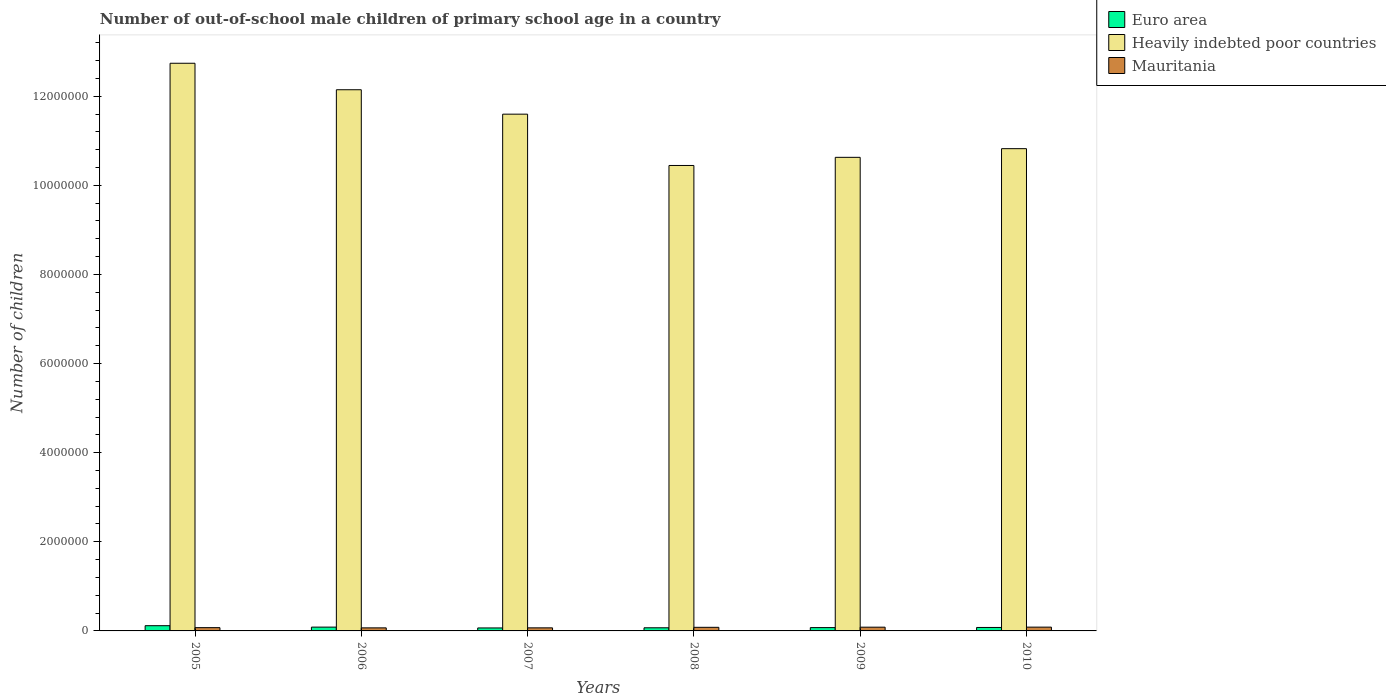How many groups of bars are there?
Offer a very short reply. 6. Are the number of bars per tick equal to the number of legend labels?
Make the answer very short. Yes. How many bars are there on the 6th tick from the left?
Ensure brevity in your answer.  3. How many bars are there on the 4th tick from the right?
Keep it short and to the point. 3. What is the label of the 1st group of bars from the left?
Your response must be concise. 2005. In how many cases, is the number of bars for a given year not equal to the number of legend labels?
Give a very brief answer. 0. What is the number of out-of-school male children in Heavily indebted poor countries in 2008?
Ensure brevity in your answer.  1.04e+07. Across all years, what is the maximum number of out-of-school male children in Heavily indebted poor countries?
Offer a very short reply. 1.27e+07. Across all years, what is the minimum number of out-of-school male children in Heavily indebted poor countries?
Provide a short and direct response. 1.04e+07. In which year was the number of out-of-school male children in Heavily indebted poor countries minimum?
Your answer should be very brief. 2008. What is the total number of out-of-school male children in Mauritania in the graph?
Give a very brief answer. 4.60e+05. What is the difference between the number of out-of-school male children in Mauritania in 2009 and that in 2010?
Provide a succinct answer. -984. What is the difference between the number of out-of-school male children in Mauritania in 2007 and the number of out-of-school male children in Heavily indebted poor countries in 2010?
Your answer should be compact. -1.08e+07. What is the average number of out-of-school male children in Heavily indebted poor countries per year?
Ensure brevity in your answer.  1.14e+07. In the year 2007, what is the difference between the number of out-of-school male children in Euro area and number of out-of-school male children in Mauritania?
Your answer should be compact. -1916. What is the ratio of the number of out-of-school male children in Heavily indebted poor countries in 2005 to that in 2010?
Provide a succinct answer. 1.18. What is the difference between the highest and the second highest number of out-of-school male children in Mauritania?
Provide a succinct answer. 984. What is the difference between the highest and the lowest number of out-of-school male children in Mauritania?
Your response must be concise. 1.65e+04. Is the sum of the number of out-of-school male children in Euro area in 2006 and 2008 greater than the maximum number of out-of-school male children in Heavily indebted poor countries across all years?
Your answer should be compact. No. What does the 2nd bar from the left in 2005 represents?
Ensure brevity in your answer.  Heavily indebted poor countries. What does the 2nd bar from the right in 2007 represents?
Make the answer very short. Heavily indebted poor countries. Are all the bars in the graph horizontal?
Your response must be concise. No. How many years are there in the graph?
Keep it short and to the point. 6. Are the values on the major ticks of Y-axis written in scientific E-notation?
Make the answer very short. No. Does the graph contain any zero values?
Give a very brief answer. No. Does the graph contain grids?
Your response must be concise. No. How many legend labels are there?
Your answer should be compact. 3. What is the title of the graph?
Offer a terse response. Number of out-of-school male children of primary school age in a country. What is the label or title of the X-axis?
Keep it short and to the point. Years. What is the label or title of the Y-axis?
Make the answer very short. Number of children. What is the Number of children of Euro area in 2005?
Provide a succinct answer. 1.17e+05. What is the Number of children in Heavily indebted poor countries in 2005?
Offer a terse response. 1.27e+07. What is the Number of children in Mauritania in 2005?
Offer a very short reply. 7.36e+04. What is the Number of children of Euro area in 2006?
Your response must be concise. 8.54e+04. What is the Number of children in Heavily indebted poor countries in 2006?
Ensure brevity in your answer.  1.21e+07. What is the Number of children of Mauritania in 2006?
Keep it short and to the point. 6.84e+04. What is the Number of children of Euro area in 2007?
Keep it short and to the point. 6.70e+04. What is the Number of children of Heavily indebted poor countries in 2007?
Offer a very short reply. 1.16e+07. What is the Number of children of Mauritania in 2007?
Your answer should be compact. 6.89e+04. What is the Number of children of Euro area in 2008?
Ensure brevity in your answer.  7.04e+04. What is the Number of children in Heavily indebted poor countries in 2008?
Provide a short and direct response. 1.04e+07. What is the Number of children of Mauritania in 2008?
Keep it short and to the point. 8.08e+04. What is the Number of children in Euro area in 2009?
Provide a short and direct response. 7.44e+04. What is the Number of children in Heavily indebted poor countries in 2009?
Offer a very short reply. 1.06e+07. What is the Number of children of Mauritania in 2009?
Your response must be concise. 8.39e+04. What is the Number of children in Euro area in 2010?
Offer a terse response. 7.76e+04. What is the Number of children in Heavily indebted poor countries in 2010?
Give a very brief answer. 1.08e+07. What is the Number of children of Mauritania in 2010?
Make the answer very short. 8.49e+04. Across all years, what is the maximum Number of children of Euro area?
Provide a short and direct response. 1.17e+05. Across all years, what is the maximum Number of children in Heavily indebted poor countries?
Provide a succinct answer. 1.27e+07. Across all years, what is the maximum Number of children in Mauritania?
Provide a short and direct response. 8.49e+04. Across all years, what is the minimum Number of children of Euro area?
Give a very brief answer. 6.70e+04. Across all years, what is the minimum Number of children in Heavily indebted poor countries?
Make the answer very short. 1.04e+07. Across all years, what is the minimum Number of children in Mauritania?
Make the answer very short. 6.84e+04. What is the total Number of children in Euro area in the graph?
Provide a succinct answer. 4.92e+05. What is the total Number of children of Heavily indebted poor countries in the graph?
Keep it short and to the point. 6.84e+07. What is the total Number of children in Mauritania in the graph?
Your answer should be very brief. 4.60e+05. What is the difference between the Number of children in Euro area in 2005 and that in 2006?
Your answer should be very brief. 3.19e+04. What is the difference between the Number of children in Heavily indebted poor countries in 2005 and that in 2006?
Make the answer very short. 5.94e+05. What is the difference between the Number of children of Mauritania in 2005 and that in 2006?
Provide a succinct answer. 5196. What is the difference between the Number of children of Euro area in 2005 and that in 2007?
Keep it short and to the point. 5.03e+04. What is the difference between the Number of children in Heavily indebted poor countries in 2005 and that in 2007?
Provide a succinct answer. 1.14e+06. What is the difference between the Number of children in Mauritania in 2005 and that in 2007?
Your answer should be compact. 4740. What is the difference between the Number of children of Euro area in 2005 and that in 2008?
Give a very brief answer. 4.69e+04. What is the difference between the Number of children of Heavily indebted poor countries in 2005 and that in 2008?
Offer a terse response. 2.29e+06. What is the difference between the Number of children of Mauritania in 2005 and that in 2008?
Your response must be concise. -7215. What is the difference between the Number of children in Euro area in 2005 and that in 2009?
Provide a short and direct response. 4.28e+04. What is the difference between the Number of children in Heavily indebted poor countries in 2005 and that in 2009?
Your answer should be compact. 2.11e+06. What is the difference between the Number of children of Mauritania in 2005 and that in 2009?
Your answer should be compact. -1.03e+04. What is the difference between the Number of children in Euro area in 2005 and that in 2010?
Provide a succinct answer. 3.97e+04. What is the difference between the Number of children in Heavily indebted poor countries in 2005 and that in 2010?
Provide a succinct answer. 1.92e+06. What is the difference between the Number of children in Mauritania in 2005 and that in 2010?
Offer a terse response. -1.13e+04. What is the difference between the Number of children in Euro area in 2006 and that in 2007?
Your response must be concise. 1.84e+04. What is the difference between the Number of children of Heavily indebted poor countries in 2006 and that in 2007?
Offer a very short reply. 5.48e+05. What is the difference between the Number of children in Mauritania in 2006 and that in 2007?
Give a very brief answer. -456. What is the difference between the Number of children of Euro area in 2006 and that in 2008?
Your answer should be compact. 1.50e+04. What is the difference between the Number of children in Heavily indebted poor countries in 2006 and that in 2008?
Your response must be concise. 1.70e+06. What is the difference between the Number of children of Mauritania in 2006 and that in 2008?
Your response must be concise. -1.24e+04. What is the difference between the Number of children in Euro area in 2006 and that in 2009?
Ensure brevity in your answer.  1.09e+04. What is the difference between the Number of children of Heavily indebted poor countries in 2006 and that in 2009?
Offer a terse response. 1.52e+06. What is the difference between the Number of children in Mauritania in 2006 and that in 2009?
Make the answer very short. -1.55e+04. What is the difference between the Number of children in Euro area in 2006 and that in 2010?
Provide a succinct answer. 7785. What is the difference between the Number of children in Heavily indebted poor countries in 2006 and that in 2010?
Your answer should be very brief. 1.32e+06. What is the difference between the Number of children of Mauritania in 2006 and that in 2010?
Ensure brevity in your answer.  -1.65e+04. What is the difference between the Number of children of Euro area in 2007 and that in 2008?
Ensure brevity in your answer.  -3445. What is the difference between the Number of children of Heavily indebted poor countries in 2007 and that in 2008?
Your response must be concise. 1.15e+06. What is the difference between the Number of children in Mauritania in 2007 and that in 2008?
Make the answer very short. -1.20e+04. What is the difference between the Number of children in Euro area in 2007 and that in 2009?
Your answer should be very brief. -7489. What is the difference between the Number of children of Heavily indebted poor countries in 2007 and that in 2009?
Offer a very short reply. 9.69e+05. What is the difference between the Number of children of Mauritania in 2007 and that in 2009?
Give a very brief answer. -1.50e+04. What is the difference between the Number of children in Euro area in 2007 and that in 2010?
Give a very brief answer. -1.06e+04. What is the difference between the Number of children in Heavily indebted poor countries in 2007 and that in 2010?
Keep it short and to the point. 7.74e+05. What is the difference between the Number of children in Mauritania in 2007 and that in 2010?
Give a very brief answer. -1.60e+04. What is the difference between the Number of children of Euro area in 2008 and that in 2009?
Provide a short and direct response. -4044. What is the difference between the Number of children in Heavily indebted poor countries in 2008 and that in 2009?
Provide a short and direct response. -1.83e+05. What is the difference between the Number of children in Mauritania in 2008 and that in 2009?
Ensure brevity in your answer.  -3057. What is the difference between the Number of children in Euro area in 2008 and that in 2010?
Your response must be concise. -7186. What is the difference between the Number of children in Heavily indebted poor countries in 2008 and that in 2010?
Your response must be concise. -3.77e+05. What is the difference between the Number of children of Mauritania in 2008 and that in 2010?
Your answer should be very brief. -4041. What is the difference between the Number of children of Euro area in 2009 and that in 2010?
Provide a short and direct response. -3142. What is the difference between the Number of children of Heavily indebted poor countries in 2009 and that in 2010?
Your answer should be compact. -1.95e+05. What is the difference between the Number of children of Mauritania in 2009 and that in 2010?
Make the answer very short. -984. What is the difference between the Number of children in Euro area in 2005 and the Number of children in Heavily indebted poor countries in 2006?
Your response must be concise. -1.20e+07. What is the difference between the Number of children in Euro area in 2005 and the Number of children in Mauritania in 2006?
Give a very brief answer. 4.89e+04. What is the difference between the Number of children of Heavily indebted poor countries in 2005 and the Number of children of Mauritania in 2006?
Your response must be concise. 1.27e+07. What is the difference between the Number of children in Euro area in 2005 and the Number of children in Heavily indebted poor countries in 2007?
Your answer should be compact. -1.15e+07. What is the difference between the Number of children in Euro area in 2005 and the Number of children in Mauritania in 2007?
Provide a succinct answer. 4.84e+04. What is the difference between the Number of children in Heavily indebted poor countries in 2005 and the Number of children in Mauritania in 2007?
Ensure brevity in your answer.  1.27e+07. What is the difference between the Number of children in Euro area in 2005 and the Number of children in Heavily indebted poor countries in 2008?
Your answer should be very brief. -1.03e+07. What is the difference between the Number of children in Euro area in 2005 and the Number of children in Mauritania in 2008?
Provide a short and direct response. 3.65e+04. What is the difference between the Number of children in Heavily indebted poor countries in 2005 and the Number of children in Mauritania in 2008?
Give a very brief answer. 1.27e+07. What is the difference between the Number of children in Euro area in 2005 and the Number of children in Heavily indebted poor countries in 2009?
Keep it short and to the point. -1.05e+07. What is the difference between the Number of children in Euro area in 2005 and the Number of children in Mauritania in 2009?
Keep it short and to the point. 3.34e+04. What is the difference between the Number of children of Heavily indebted poor countries in 2005 and the Number of children of Mauritania in 2009?
Provide a succinct answer. 1.27e+07. What is the difference between the Number of children of Euro area in 2005 and the Number of children of Heavily indebted poor countries in 2010?
Offer a terse response. -1.07e+07. What is the difference between the Number of children of Euro area in 2005 and the Number of children of Mauritania in 2010?
Provide a succinct answer. 3.24e+04. What is the difference between the Number of children in Heavily indebted poor countries in 2005 and the Number of children in Mauritania in 2010?
Ensure brevity in your answer.  1.27e+07. What is the difference between the Number of children in Euro area in 2006 and the Number of children in Heavily indebted poor countries in 2007?
Your response must be concise. -1.15e+07. What is the difference between the Number of children in Euro area in 2006 and the Number of children in Mauritania in 2007?
Your response must be concise. 1.65e+04. What is the difference between the Number of children of Heavily indebted poor countries in 2006 and the Number of children of Mauritania in 2007?
Your response must be concise. 1.21e+07. What is the difference between the Number of children of Euro area in 2006 and the Number of children of Heavily indebted poor countries in 2008?
Offer a very short reply. -1.04e+07. What is the difference between the Number of children of Euro area in 2006 and the Number of children of Mauritania in 2008?
Your answer should be compact. 4545. What is the difference between the Number of children of Heavily indebted poor countries in 2006 and the Number of children of Mauritania in 2008?
Offer a terse response. 1.21e+07. What is the difference between the Number of children of Euro area in 2006 and the Number of children of Heavily indebted poor countries in 2009?
Provide a short and direct response. -1.05e+07. What is the difference between the Number of children in Euro area in 2006 and the Number of children in Mauritania in 2009?
Give a very brief answer. 1488. What is the difference between the Number of children in Heavily indebted poor countries in 2006 and the Number of children in Mauritania in 2009?
Provide a succinct answer. 1.21e+07. What is the difference between the Number of children of Euro area in 2006 and the Number of children of Heavily indebted poor countries in 2010?
Make the answer very short. -1.07e+07. What is the difference between the Number of children of Euro area in 2006 and the Number of children of Mauritania in 2010?
Your answer should be compact. 504. What is the difference between the Number of children in Heavily indebted poor countries in 2006 and the Number of children in Mauritania in 2010?
Give a very brief answer. 1.21e+07. What is the difference between the Number of children in Euro area in 2007 and the Number of children in Heavily indebted poor countries in 2008?
Ensure brevity in your answer.  -1.04e+07. What is the difference between the Number of children in Euro area in 2007 and the Number of children in Mauritania in 2008?
Your answer should be very brief. -1.39e+04. What is the difference between the Number of children of Heavily indebted poor countries in 2007 and the Number of children of Mauritania in 2008?
Make the answer very short. 1.15e+07. What is the difference between the Number of children of Euro area in 2007 and the Number of children of Heavily indebted poor countries in 2009?
Provide a short and direct response. -1.06e+07. What is the difference between the Number of children in Euro area in 2007 and the Number of children in Mauritania in 2009?
Offer a very short reply. -1.69e+04. What is the difference between the Number of children of Heavily indebted poor countries in 2007 and the Number of children of Mauritania in 2009?
Offer a terse response. 1.15e+07. What is the difference between the Number of children in Euro area in 2007 and the Number of children in Heavily indebted poor countries in 2010?
Your response must be concise. -1.08e+07. What is the difference between the Number of children in Euro area in 2007 and the Number of children in Mauritania in 2010?
Ensure brevity in your answer.  -1.79e+04. What is the difference between the Number of children in Heavily indebted poor countries in 2007 and the Number of children in Mauritania in 2010?
Provide a succinct answer. 1.15e+07. What is the difference between the Number of children in Euro area in 2008 and the Number of children in Heavily indebted poor countries in 2009?
Provide a short and direct response. -1.06e+07. What is the difference between the Number of children in Euro area in 2008 and the Number of children in Mauritania in 2009?
Ensure brevity in your answer.  -1.35e+04. What is the difference between the Number of children in Heavily indebted poor countries in 2008 and the Number of children in Mauritania in 2009?
Offer a very short reply. 1.04e+07. What is the difference between the Number of children in Euro area in 2008 and the Number of children in Heavily indebted poor countries in 2010?
Your answer should be compact. -1.08e+07. What is the difference between the Number of children of Euro area in 2008 and the Number of children of Mauritania in 2010?
Your answer should be very brief. -1.45e+04. What is the difference between the Number of children of Heavily indebted poor countries in 2008 and the Number of children of Mauritania in 2010?
Your response must be concise. 1.04e+07. What is the difference between the Number of children of Euro area in 2009 and the Number of children of Heavily indebted poor countries in 2010?
Provide a succinct answer. -1.07e+07. What is the difference between the Number of children in Euro area in 2009 and the Number of children in Mauritania in 2010?
Ensure brevity in your answer.  -1.04e+04. What is the difference between the Number of children in Heavily indebted poor countries in 2009 and the Number of children in Mauritania in 2010?
Make the answer very short. 1.05e+07. What is the average Number of children of Euro area per year?
Give a very brief answer. 8.20e+04. What is the average Number of children in Heavily indebted poor countries per year?
Your response must be concise. 1.14e+07. What is the average Number of children in Mauritania per year?
Your response must be concise. 7.67e+04. In the year 2005, what is the difference between the Number of children of Euro area and Number of children of Heavily indebted poor countries?
Make the answer very short. -1.26e+07. In the year 2005, what is the difference between the Number of children in Euro area and Number of children in Mauritania?
Your response must be concise. 4.37e+04. In the year 2005, what is the difference between the Number of children of Heavily indebted poor countries and Number of children of Mauritania?
Your answer should be compact. 1.27e+07. In the year 2006, what is the difference between the Number of children of Euro area and Number of children of Heavily indebted poor countries?
Give a very brief answer. -1.21e+07. In the year 2006, what is the difference between the Number of children of Euro area and Number of children of Mauritania?
Ensure brevity in your answer.  1.70e+04. In the year 2006, what is the difference between the Number of children in Heavily indebted poor countries and Number of children in Mauritania?
Your response must be concise. 1.21e+07. In the year 2007, what is the difference between the Number of children in Euro area and Number of children in Heavily indebted poor countries?
Ensure brevity in your answer.  -1.15e+07. In the year 2007, what is the difference between the Number of children in Euro area and Number of children in Mauritania?
Make the answer very short. -1916. In the year 2007, what is the difference between the Number of children of Heavily indebted poor countries and Number of children of Mauritania?
Your answer should be compact. 1.15e+07. In the year 2008, what is the difference between the Number of children in Euro area and Number of children in Heavily indebted poor countries?
Your answer should be compact. -1.04e+07. In the year 2008, what is the difference between the Number of children of Euro area and Number of children of Mauritania?
Your answer should be compact. -1.04e+04. In the year 2008, what is the difference between the Number of children in Heavily indebted poor countries and Number of children in Mauritania?
Provide a short and direct response. 1.04e+07. In the year 2009, what is the difference between the Number of children in Euro area and Number of children in Heavily indebted poor countries?
Your answer should be very brief. -1.06e+07. In the year 2009, what is the difference between the Number of children of Euro area and Number of children of Mauritania?
Your response must be concise. -9439. In the year 2009, what is the difference between the Number of children in Heavily indebted poor countries and Number of children in Mauritania?
Your answer should be very brief. 1.05e+07. In the year 2010, what is the difference between the Number of children of Euro area and Number of children of Heavily indebted poor countries?
Keep it short and to the point. -1.07e+07. In the year 2010, what is the difference between the Number of children of Euro area and Number of children of Mauritania?
Keep it short and to the point. -7281. In the year 2010, what is the difference between the Number of children in Heavily indebted poor countries and Number of children in Mauritania?
Give a very brief answer. 1.07e+07. What is the ratio of the Number of children in Euro area in 2005 to that in 2006?
Make the answer very short. 1.37. What is the ratio of the Number of children of Heavily indebted poor countries in 2005 to that in 2006?
Provide a short and direct response. 1.05. What is the ratio of the Number of children in Mauritania in 2005 to that in 2006?
Your response must be concise. 1.08. What is the ratio of the Number of children in Euro area in 2005 to that in 2007?
Your answer should be very brief. 1.75. What is the ratio of the Number of children of Heavily indebted poor countries in 2005 to that in 2007?
Your answer should be compact. 1.1. What is the ratio of the Number of children in Mauritania in 2005 to that in 2007?
Provide a short and direct response. 1.07. What is the ratio of the Number of children of Euro area in 2005 to that in 2008?
Offer a very short reply. 1.67. What is the ratio of the Number of children in Heavily indebted poor countries in 2005 to that in 2008?
Make the answer very short. 1.22. What is the ratio of the Number of children in Mauritania in 2005 to that in 2008?
Make the answer very short. 0.91. What is the ratio of the Number of children in Euro area in 2005 to that in 2009?
Your response must be concise. 1.58. What is the ratio of the Number of children in Heavily indebted poor countries in 2005 to that in 2009?
Provide a succinct answer. 1.2. What is the ratio of the Number of children of Mauritania in 2005 to that in 2009?
Offer a terse response. 0.88. What is the ratio of the Number of children of Euro area in 2005 to that in 2010?
Keep it short and to the point. 1.51. What is the ratio of the Number of children in Heavily indebted poor countries in 2005 to that in 2010?
Offer a very short reply. 1.18. What is the ratio of the Number of children of Mauritania in 2005 to that in 2010?
Your answer should be very brief. 0.87. What is the ratio of the Number of children of Euro area in 2006 to that in 2007?
Keep it short and to the point. 1.28. What is the ratio of the Number of children in Heavily indebted poor countries in 2006 to that in 2007?
Keep it short and to the point. 1.05. What is the ratio of the Number of children in Euro area in 2006 to that in 2008?
Your answer should be very brief. 1.21. What is the ratio of the Number of children of Heavily indebted poor countries in 2006 to that in 2008?
Your response must be concise. 1.16. What is the ratio of the Number of children in Mauritania in 2006 to that in 2008?
Make the answer very short. 0.85. What is the ratio of the Number of children of Euro area in 2006 to that in 2009?
Offer a terse response. 1.15. What is the ratio of the Number of children of Heavily indebted poor countries in 2006 to that in 2009?
Provide a succinct answer. 1.14. What is the ratio of the Number of children in Mauritania in 2006 to that in 2009?
Ensure brevity in your answer.  0.82. What is the ratio of the Number of children in Euro area in 2006 to that in 2010?
Provide a succinct answer. 1.1. What is the ratio of the Number of children of Heavily indebted poor countries in 2006 to that in 2010?
Your answer should be compact. 1.12. What is the ratio of the Number of children in Mauritania in 2006 to that in 2010?
Provide a succinct answer. 0.81. What is the ratio of the Number of children of Euro area in 2007 to that in 2008?
Your answer should be compact. 0.95. What is the ratio of the Number of children of Heavily indebted poor countries in 2007 to that in 2008?
Your answer should be very brief. 1.11. What is the ratio of the Number of children of Mauritania in 2007 to that in 2008?
Provide a short and direct response. 0.85. What is the ratio of the Number of children of Euro area in 2007 to that in 2009?
Ensure brevity in your answer.  0.9. What is the ratio of the Number of children in Heavily indebted poor countries in 2007 to that in 2009?
Your answer should be very brief. 1.09. What is the ratio of the Number of children in Mauritania in 2007 to that in 2009?
Provide a short and direct response. 0.82. What is the ratio of the Number of children in Euro area in 2007 to that in 2010?
Provide a succinct answer. 0.86. What is the ratio of the Number of children in Heavily indebted poor countries in 2007 to that in 2010?
Your answer should be compact. 1.07. What is the ratio of the Number of children of Mauritania in 2007 to that in 2010?
Provide a succinct answer. 0.81. What is the ratio of the Number of children in Euro area in 2008 to that in 2009?
Your response must be concise. 0.95. What is the ratio of the Number of children of Heavily indebted poor countries in 2008 to that in 2009?
Offer a terse response. 0.98. What is the ratio of the Number of children in Mauritania in 2008 to that in 2009?
Provide a short and direct response. 0.96. What is the ratio of the Number of children of Euro area in 2008 to that in 2010?
Provide a short and direct response. 0.91. What is the ratio of the Number of children in Heavily indebted poor countries in 2008 to that in 2010?
Provide a short and direct response. 0.97. What is the ratio of the Number of children of Mauritania in 2008 to that in 2010?
Make the answer very short. 0.95. What is the ratio of the Number of children in Euro area in 2009 to that in 2010?
Your response must be concise. 0.96. What is the ratio of the Number of children in Mauritania in 2009 to that in 2010?
Offer a terse response. 0.99. What is the difference between the highest and the second highest Number of children in Euro area?
Ensure brevity in your answer.  3.19e+04. What is the difference between the highest and the second highest Number of children of Heavily indebted poor countries?
Give a very brief answer. 5.94e+05. What is the difference between the highest and the second highest Number of children in Mauritania?
Offer a terse response. 984. What is the difference between the highest and the lowest Number of children of Euro area?
Give a very brief answer. 5.03e+04. What is the difference between the highest and the lowest Number of children in Heavily indebted poor countries?
Provide a succinct answer. 2.29e+06. What is the difference between the highest and the lowest Number of children in Mauritania?
Your response must be concise. 1.65e+04. 